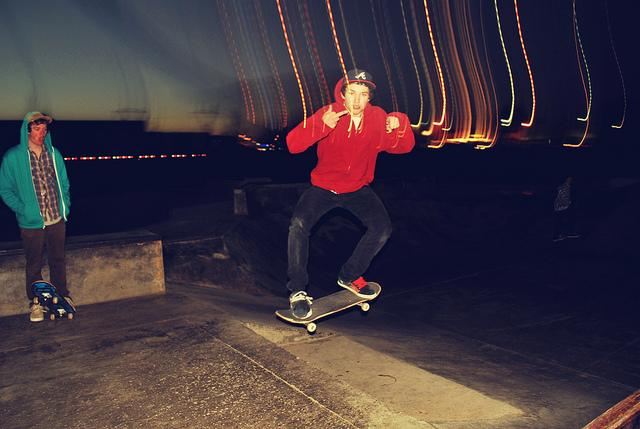The boy skateboarding is a fan of what baseball team? Please explain your reasoning. atlanta braves. The boy on the skateboard has a baseball cap with the atlanta braves logo on it. 